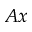<formula> <loc_0><loc_0><loc_500><loc_500>A x</formula> 